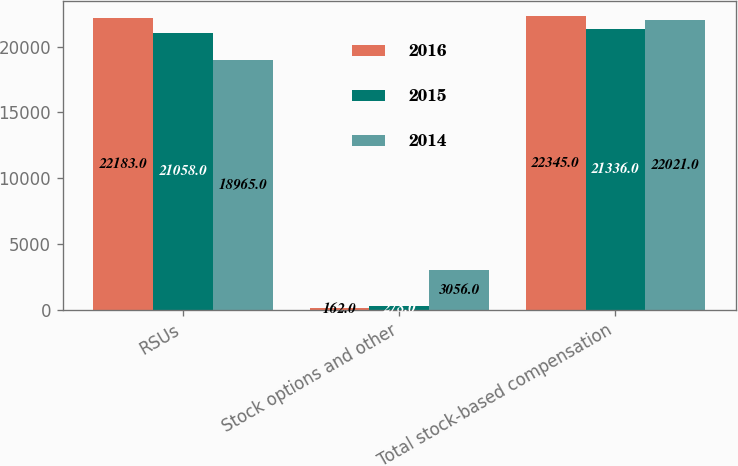Convert chart. <chart><loc_0><loc_0><loc_500><loc_500><stacked_bar_chart><ecel><fcel>RSUs<fcel>Stock options and other<fcel>Total stock-based compensation<nl><fcel>2016<fcel>22183<fcel>162<fcel>22345<nl><fcel>2015<fcel>21058<fcel>278<fcel>21336<nl><fcel>2014<fcel>18965<fcel>3056<fcel>22021<nl></chart> 